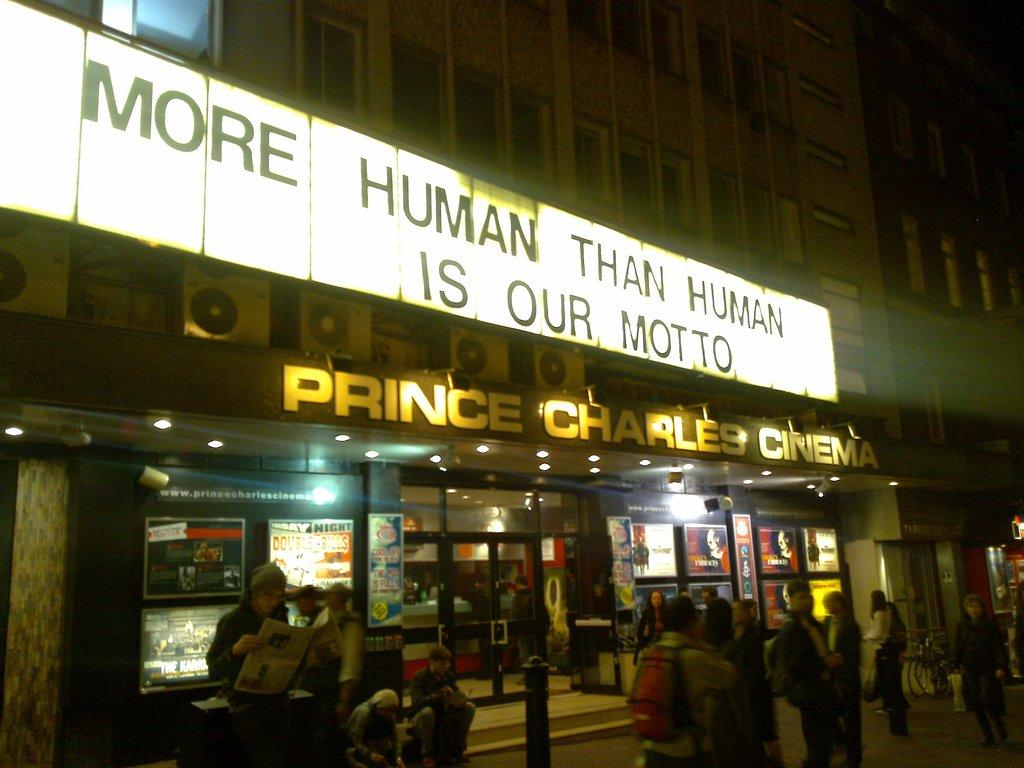<image>
Create a compact narrative representing the image presented. A cinema with the slogan More Human Than Human Is Our Motto 